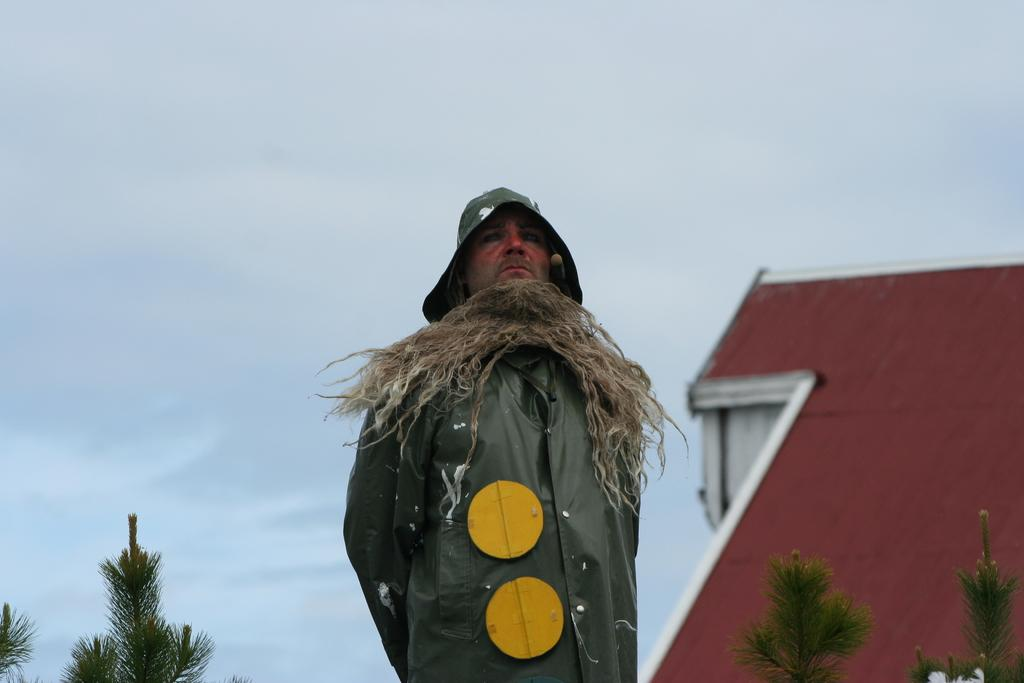What is the main subject of the image? There is a person standing in the image. What can be seen behind the person? There are trees and a building behind the person. What is visible in the background of the image? The sky is visible in the background of the image. What type of office equipment can be seen on the person's desk in the image? There is no desk or office equipment present in the image; it features a person standing with trees and a building in the background. 